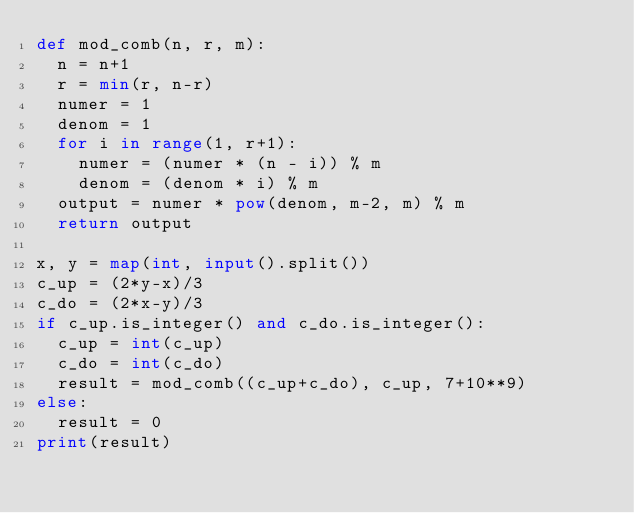Convert code to text. <code><loc_0><loc_0><loc_500><loc_500><_Python_>def mod_comb(n, r, m):
  n = n+1
  r = min(r, n-r)
  numer = 1
  denom = 1
  for i in range(1, r+1):
    numer = (numer * (n - i)) % m
    denom = (denom * i) % m
  output = numer * pow(denom, m-2, m) % m
  return output

x, y = map(int, input().split())
c_up = (2*y-x)/3
c_do = (2*x-y)/3
if c_up.is_integer() and c_do.is_integer():
  c_up = int(c_up)
  c_do = int(c_do)
  result = mod_comb((c_up+c_do), c_up, 7+10**9)
else:
  result = 0
print(result)
</code> 